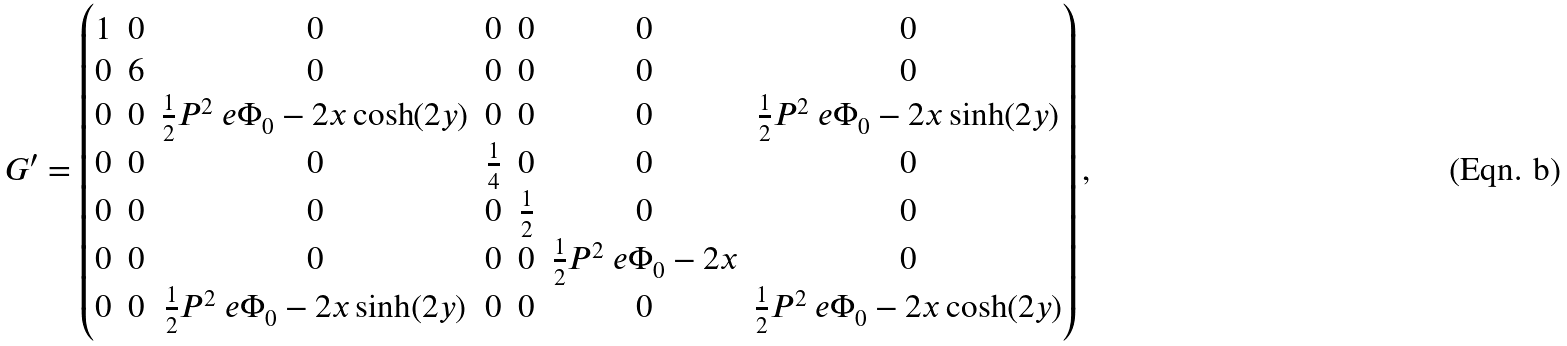<formula> <loc_0><loc_0><loc_500><loc_500>G ^ { \prime } = \begin{pmatrix} 1 & 0 & 0 & 0 & 0 & 0 & 0 \\ 0 & 6 & 0 & 0 & 0 & 0 & 0 \\ 0 & 0 & \frac { 1 } { 2 } P ^ { 2 } \ e { \Phi _ { 0 } - 2 x } \cosh ( 2 y ) & 0 & 0 & 0 & \frac { 1 } { 2 } P ^ { 2 } \ e { \Phi _ { 0 } - 2 x } \sinh ( 2 y ) \\ 0 & 0 & 0 & \frac { 1 } { 4 } & 0 & 0 & 0 \\ 0 & 0 & 0 & 0 & \frac { 1 } { 2 } & 0 & 0 \\ 0 & 0 & 0 & 0 & 0 & \frac { 1 } { 2 } P ^ { 2 } \ e { \Phi _ { 0 } - 2 x } & 0 \\ 0 & 0 & \frac { 1 } { 2 } P ^ { 2 } \ e { \Phi _ { 0 } - 2 x } \sinh ( 2 y ) & 0 & 0 & 0 & \frac { 1 } { 2 } P ^ { 2 } \ e { \Phi _ { 0 } - 2 x } \cosh ( 2 y ) \end{pmatrix} ,</formula> 